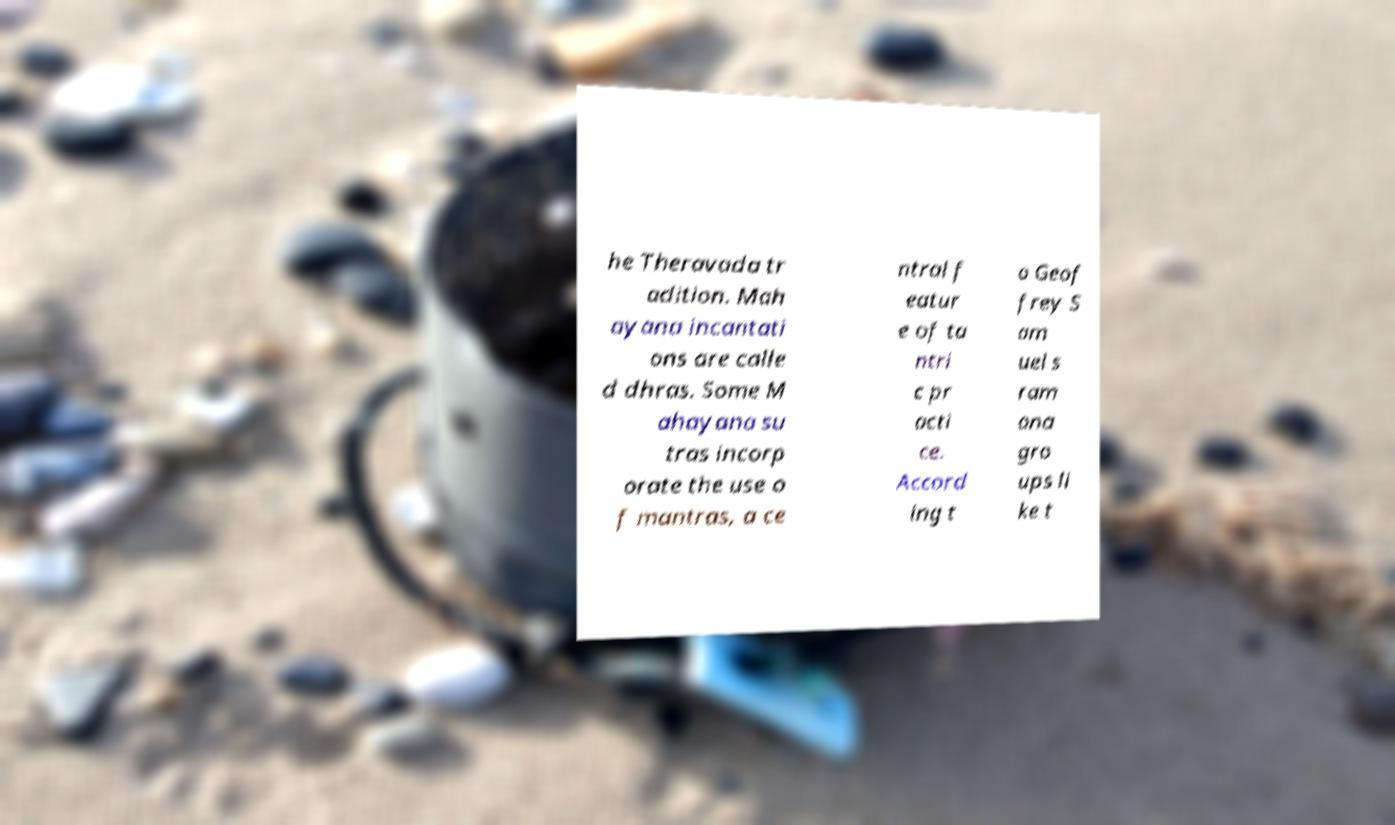Please read and relay the text visible in this image. What does it say? he Theravada tr adition. Mah ayana incantati ons are calle d dhras. Some M ahayana su tras incorp orate the use o f mantras, a ce ntral f eatur e of ta ntri c pr acti ce. Accord ing t o Geof frey S am uel s ram ana gro ups li ke t 